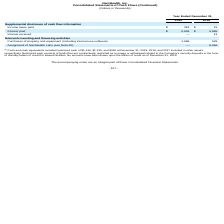From Nanthealth's financial document, What are the respective restricted cash included in the cash and cash equivalents in 2019 and 2017 respectively? The document shows two values: $1,136 and $350 (in thousands). From the document: "ts included restricted cash of $1,136, $1,136, and $350 at December 31, 2019, 2018, and 2017 included in other assets, respectively. Restricted cash c..." Also, What are the respective restricted cash included in the cash and cash equivalents in 2018 and 2017 respectively? The document shows two values: $1,136 and $350 (in thousands). From the document: "ts included restricted cash of $1,136, $1,136, and $350 at December 31, 2019, 2018, and 2017 included in other assets, respectively. Restricted cash c..." Also, What are the respective income taxes paid in 2018 and 2019? The document shows two values: $15 and $318 (in thousands). From the document: "Income taxes paid $ 318 $ 15 Income taxes paid $ 318 $ 15..." Also, can you calculate: What is the total income taxes paid in 2018 and 2019? Based on the calculation: 15 + 318 , the result is 333 (in thousands). This is based on the information: "Income taxes paid $ 318 $ 15 Income taxes paid $ 318 $ 15..." The key data points involved are: 15, 318. Also, can you calculate: What is the average interest paid by the company in 2018 and 2019? To answer this question, I need to perform calculations using the financial data. The calculation is: (5,909 + 5,885)/2 , which equals 5897 (in thousands). This is based on the information: "Interest paid $ 5,909 $ 5,885 Interest paid $ 5,909 $ 5,885..." The key data points involved are: 5,885, 5,909. Also, can you calculate: What is the percentage change in the interest paid between 2018 and 2019? To answer this question, I need to perform calculations using the financial data. The calculation is: (5,909 - 5,885)/5,885 , which equals 0.41 (percentage). This is based on the information: "Interest paid $ 5,909 $ 5,885 Interest paid $ 5,909 $ 5,885..." The key data points involved are: 5,885, 5,909. 